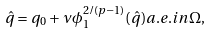<formula> <loc_0><loc_0><loc_500><loc_500>\hat { q } = q _ { 0 } + \nu \phi _ { 1 } ^ { 2 / ( p - 1 ) } ( \hat { q } ) a . e . i n \Omega ,</formula> 